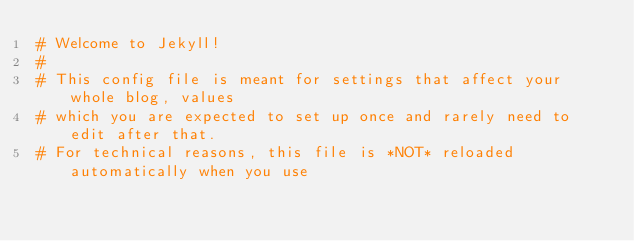Convert code to text. <code><loc_0><loc_0><loc_500><loc_500><_YAML_># Welcome to Jekyll!
#
# This config file is meant for settings that affect your whole blog, values
# which you are expected to set up once and rarely need to edit after that.
# For technical reasons, this file is *NOT* reloaded automatically when you use</code> 